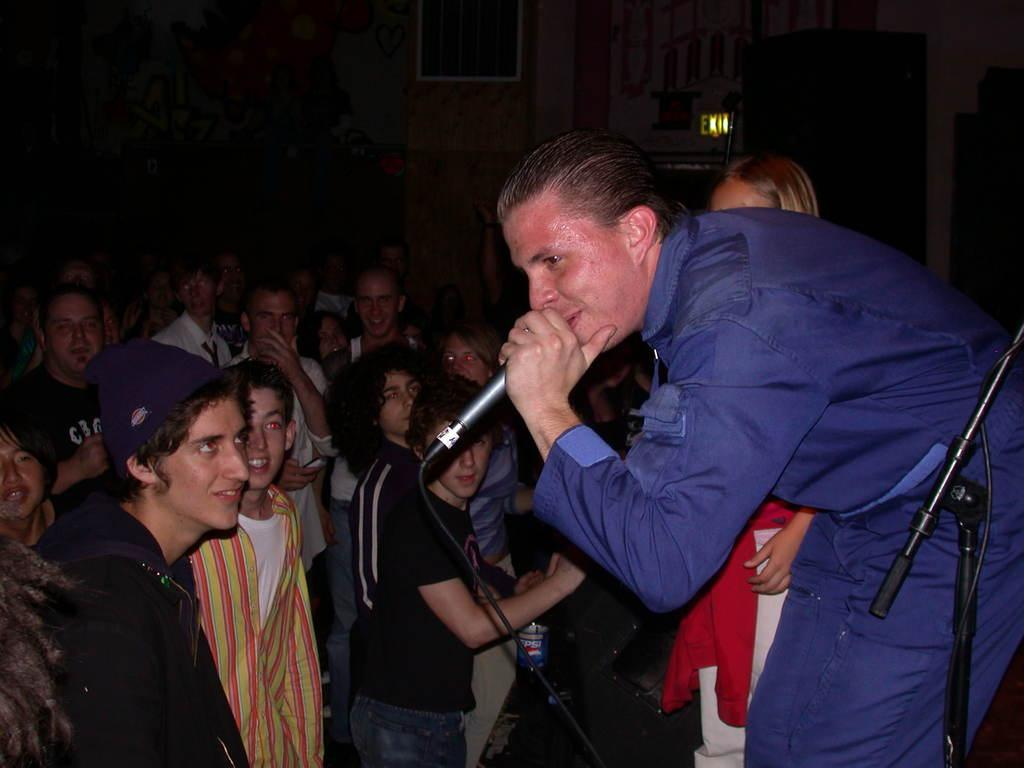Who is the main subject in the image? There is a man in the image. What is the man holding in the image? The man is holding a microphone. Can you describe the background of the image? There are other persons in the background of the image. What architectural feature is visible in the image? There is a door visible in the image. What type of pigs can be seen eating popcorn in the image? There are no pigs or popcorn present in the image. 